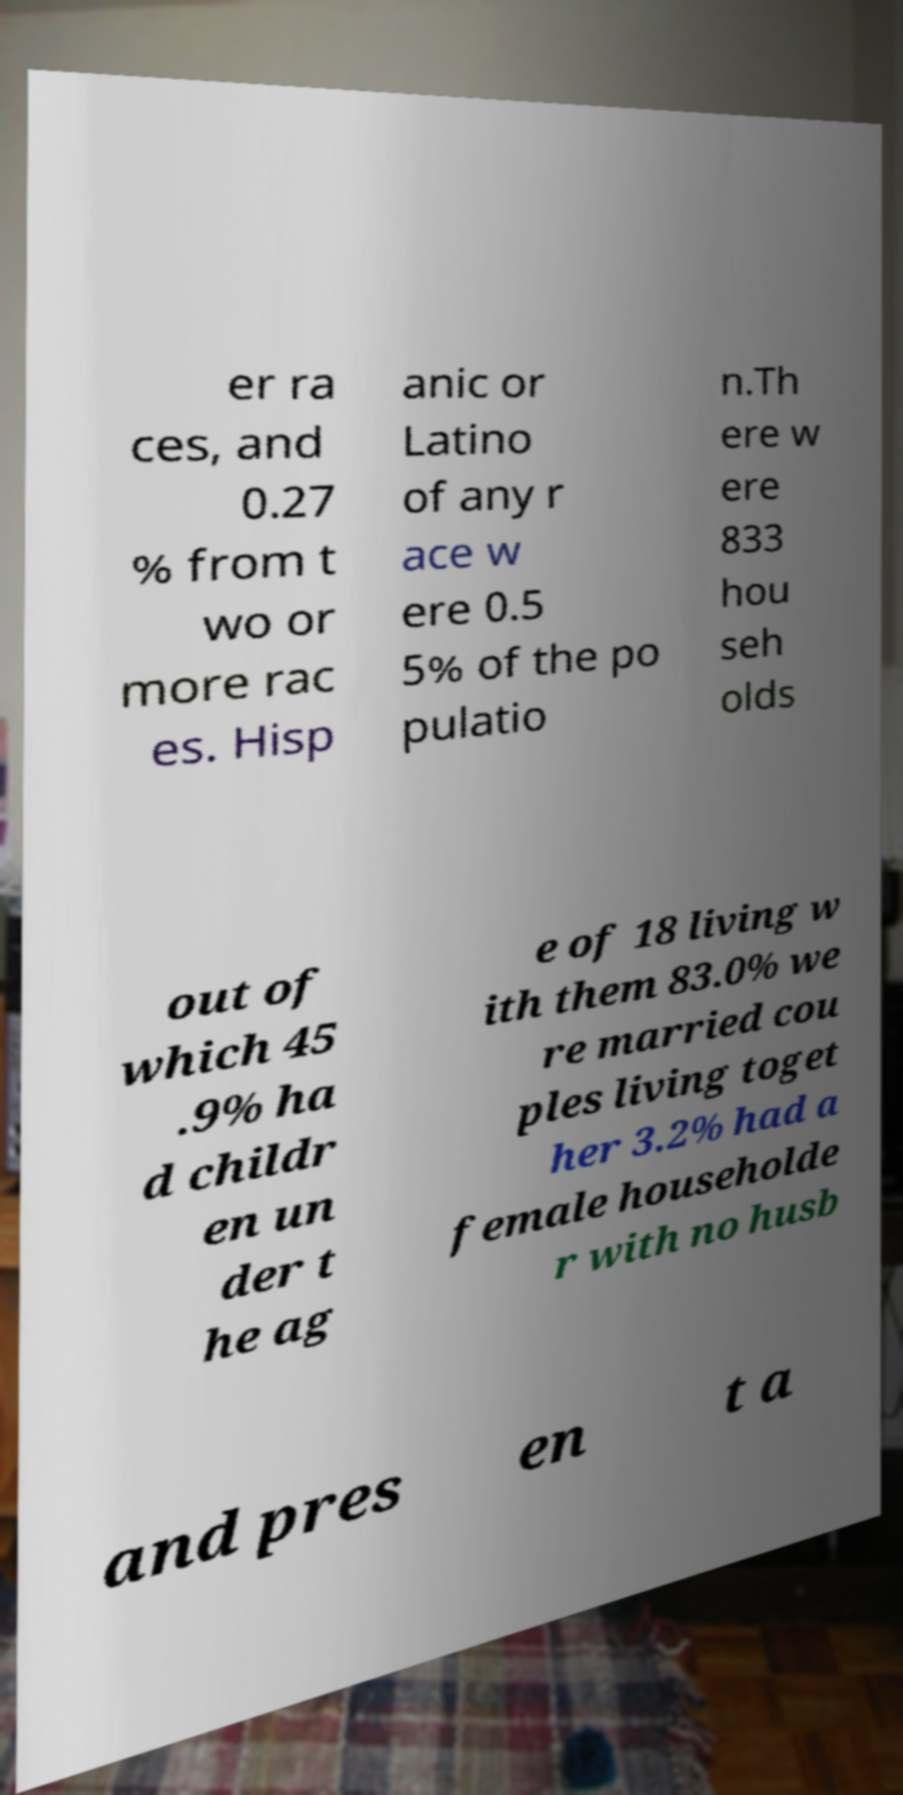Could you assist in decoding the text presented in this image and type it out clearly? er ra ces, and 0.27 % from t wo or more rac es. Hisp anic or Latino of any r ace w ere 0.5 5% of the po pulatio n.Th ere w ere 833 hou seh olds out of which 45 .9% ha d childr en un der t he ag e of 18 living w ith them 83.0% we re married cou ples living toget her 3.2% had a female householde r with no husb and pres en t a 